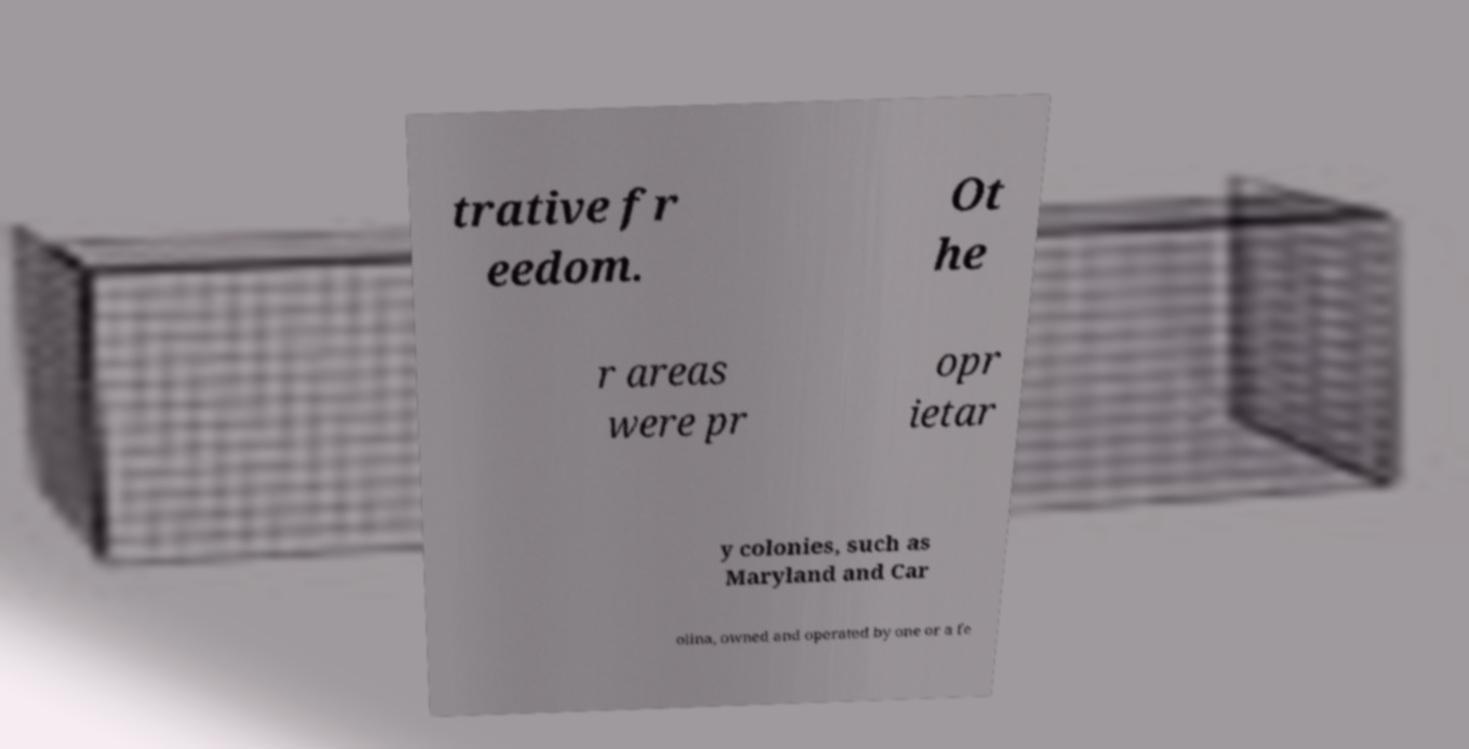Could you extract and type out the text from this image? trative fr eedom. Ot he r areas were pr opr ietar y colonies, such as Maryland and Car olina, owned and operated by one or a fe 